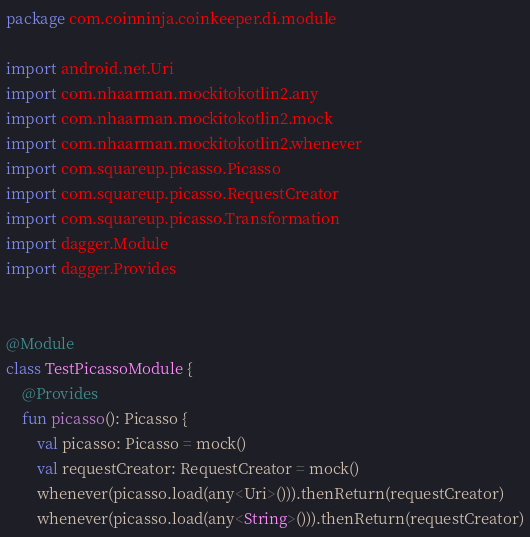Convert code to text. <code><loc_0><loc_0><loc_500><loc_500><_Kotlin_>package com.coinninja.coinkeeper.di.module

import android.net.Uri
import com.nhaarman.mockitokotlin2.any
import com.nhaarman.mockitokotlin2.mock
import com.nhaarman.mockitokotlin2.whenever
import com.squareup.picasso.Picasso
import com.squareup.picasso.RequestCreator
import com.squareup.picasso.Transformation
import dagger.Module
import dagger.Provides


@Module
class TestPicassoModule {
    @Provides
    fun picasso(): Picasso {
        val picasso: Picasso = mock()
        val requestCreator: RequestCreator = mock()
        whenever(picasso.load(any<Uri>())).thenReturn(requestCreator)
        whenever(picasso.load(any<String>())).thenReturn(requestCreator)</code> 